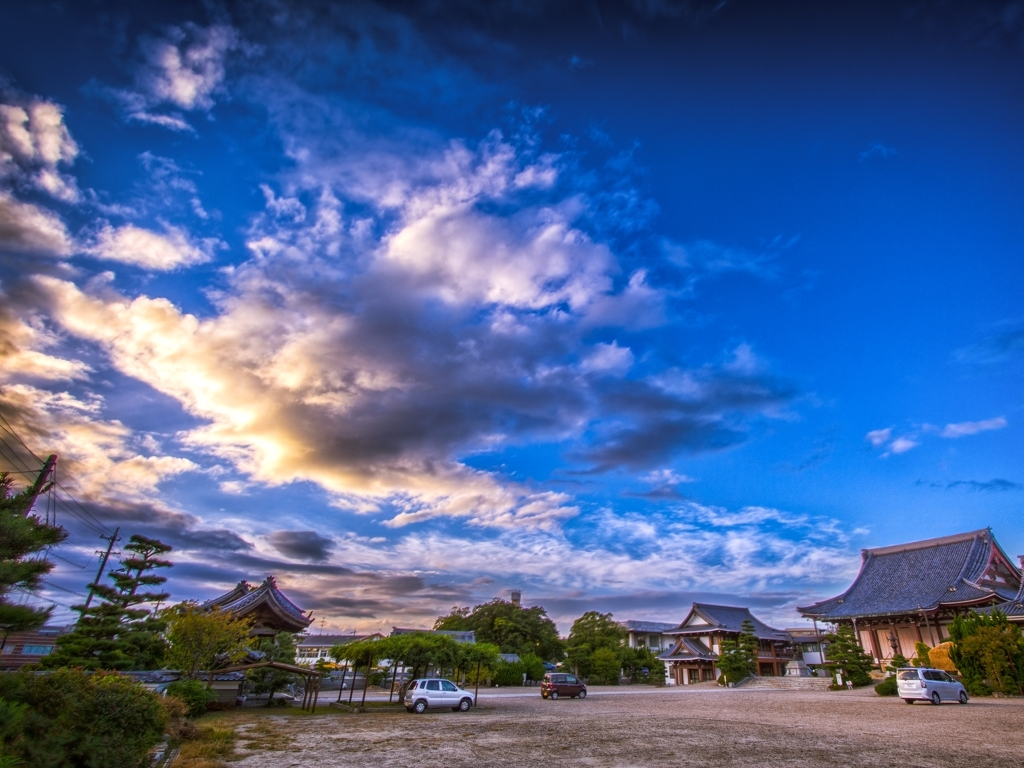What is the impression created by the color of the image? The colors in the image create a vibrant and dynamic atmosphere. The vivid blue of the sky, punctuated by the golden hues of the sun's rays piercing through the clouds, combine to give a sense of energy and liveliness. While 'dazzling' might not perfectly depict the entirety of the image, it comes close to describing the bright and intense colors at play. 